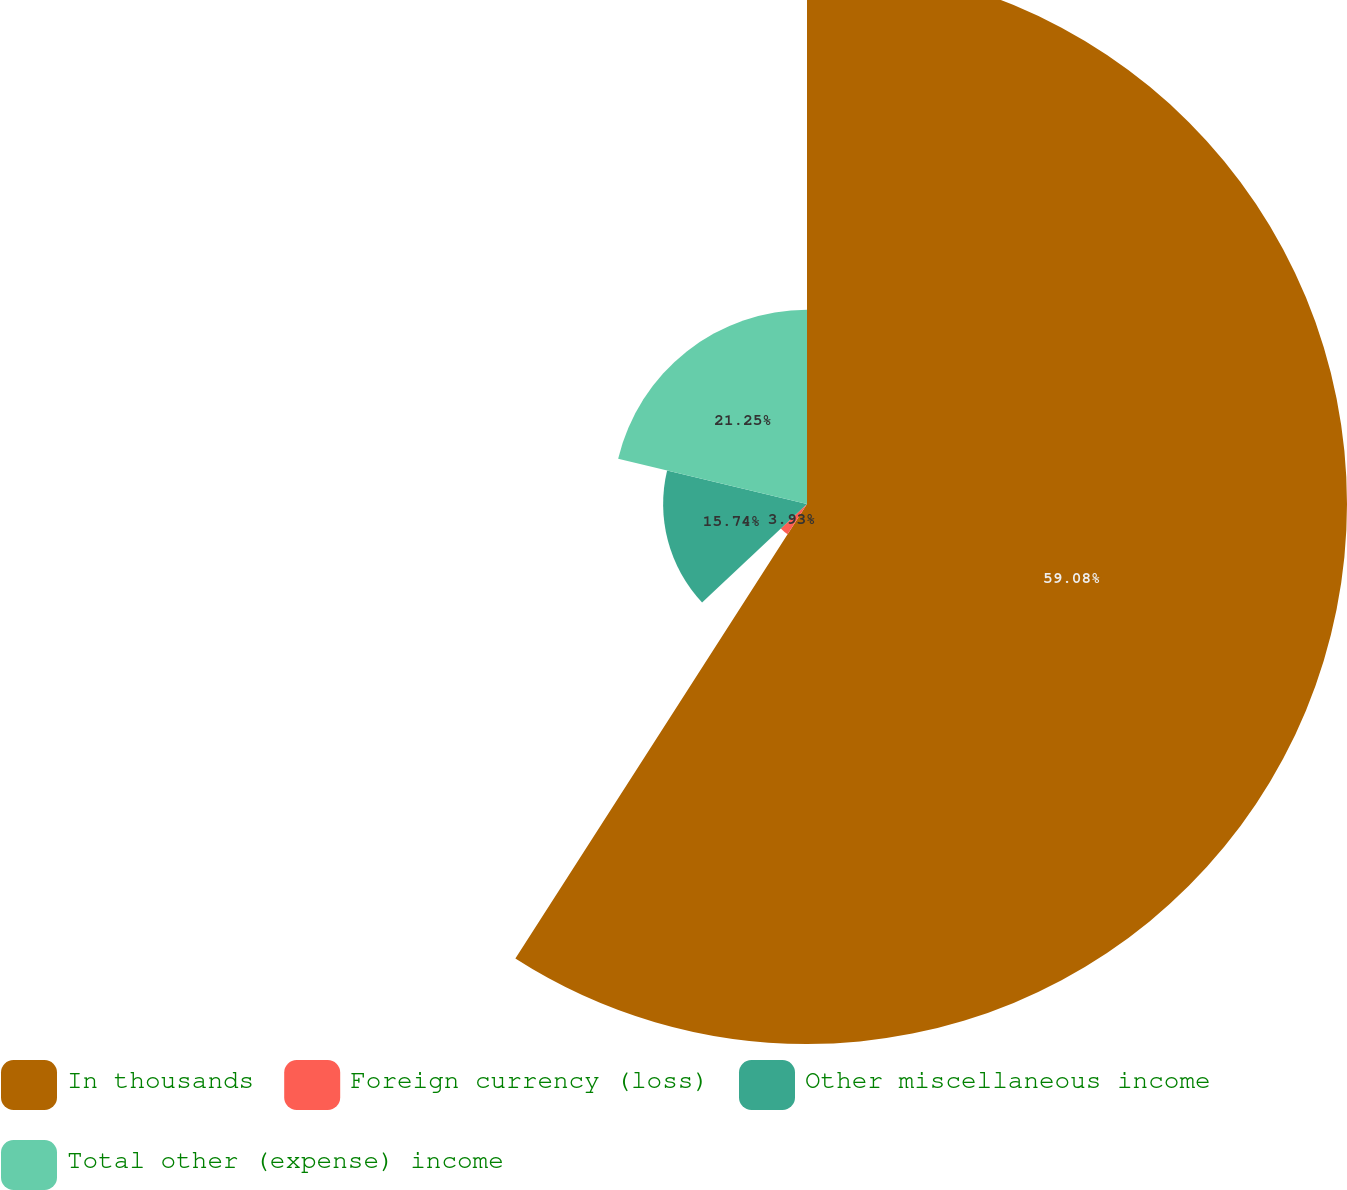Convert chart. <chart><loc_0><loc_0><loc_500><loc_500><pie_chart><fcel>In thousands<fcel>Foreign currency (loss)<fcel>Other miscellaneous income<fcel>Total other (expense) income<nl><fcel>59.08%<fcel>3.93%<fcel>15.74%<fcel>21.25%<nl></chart> 